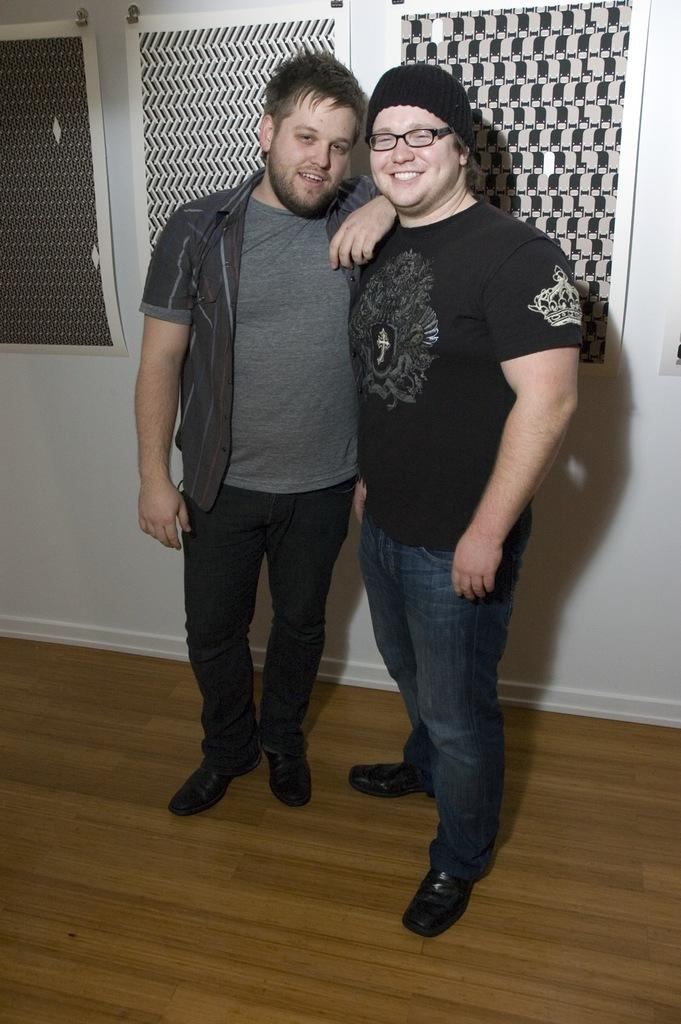How many people are in the image? There are two persons in the image. What is the facial expression of the persons in the image? The persons are standing with a smile on their faces. What can be seen on the wall in the background of the image? There are papers hanging on the wall in the background of the image. What type of ocean can be seen in the image? There is no ocean present in the image; it features two persons standing with a smile on their faces. How many people are in the crowd in the image? There is no crowd present in the image; it features two persons standing with a smile on their faces. 